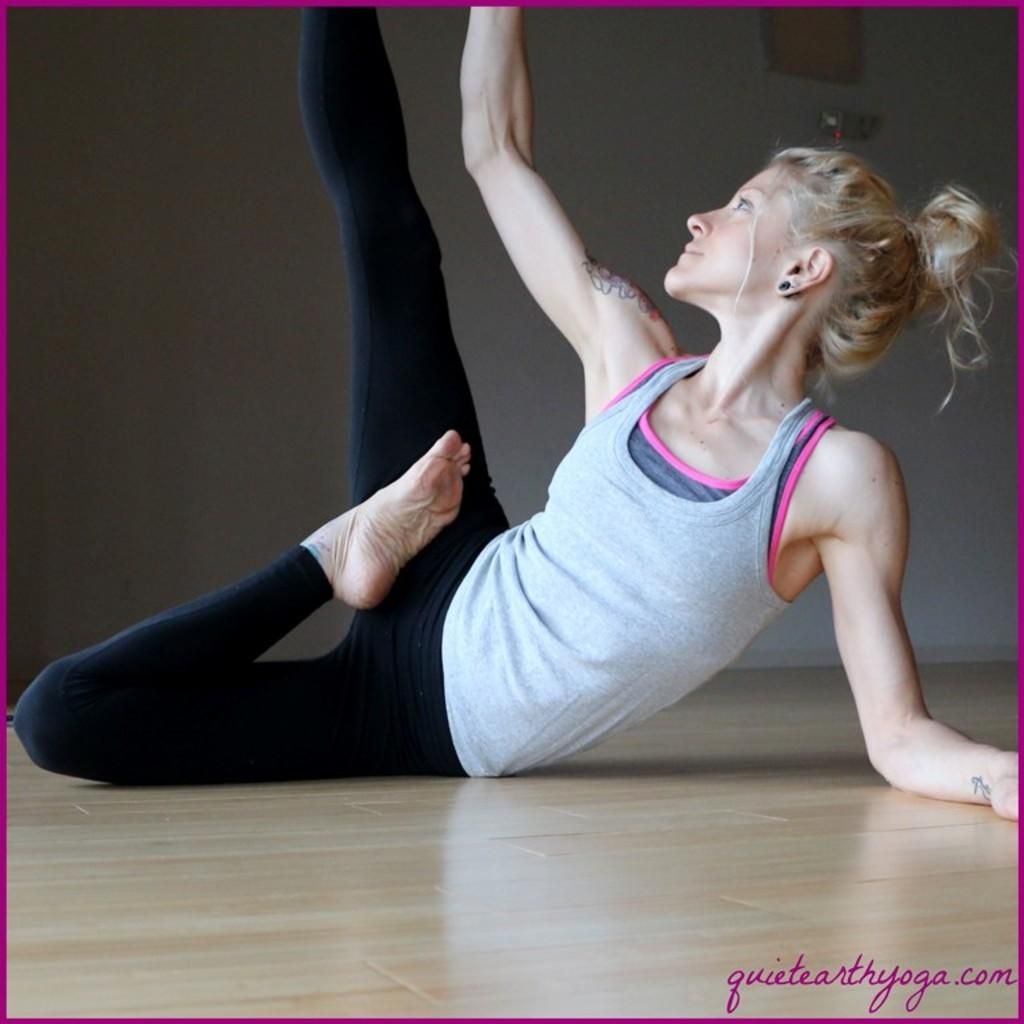Who is present in the image? There is a woman in the image. What is the woman doing in the image? The woman appears to be doing exercise in the image. Where is the woman located in the image? The woman is on the floor in the image. What can be seen in the background of the image? There is a wall in the background of the image. What type of power is being generated by the woman in the image? There is no indication in the image that the woman is generating any power. 